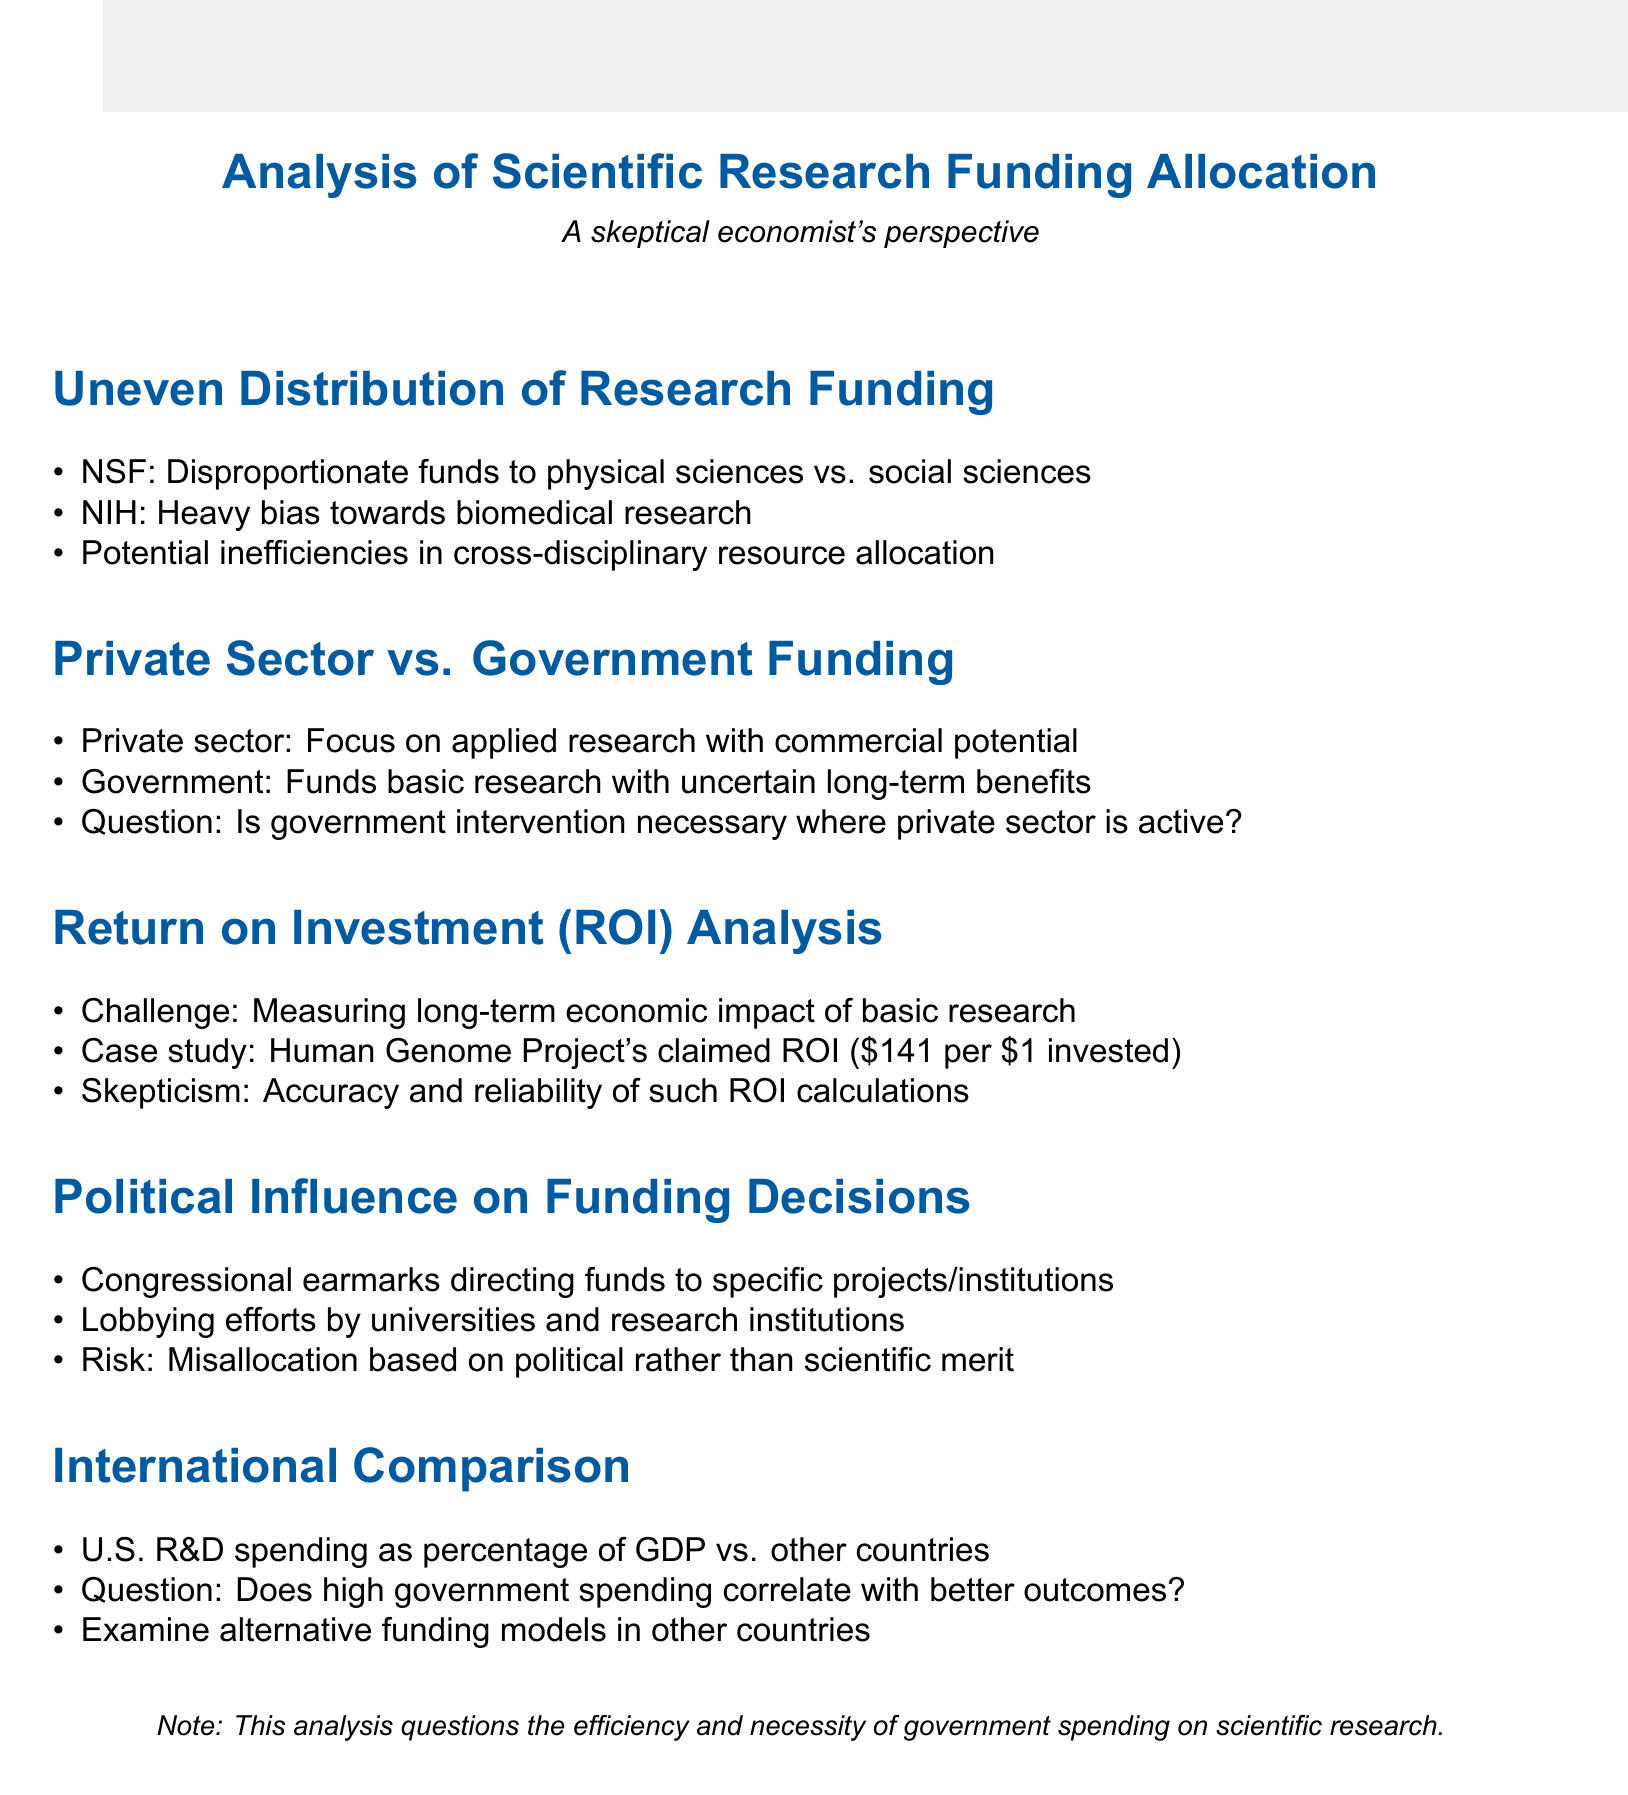What funding agency favors physical sciences? The document states that the National Science Foundation allocates disproportionate funds to physical sciences compared to social sciences.
Answer: National Science Foundation Which research field does the National Institutes of Health favor? The details mention that the NIH heavily favors biomedical research over other health-related fields.
Answer: Biomedical research What is the estimated ROI of the Human Genome Project? The document specifies the Human Genome Project's estimated ROI as $141 for every $1 invested.
Answer: $141 What is a risk mentioned regarding political influence on funding decisions? The document highlights the risk of misallocation of resources based on political rather than scientific merit.
Answer: Misallocation Which countries are compared to the U.S. in R&D spending? The document mentions China, Japan, and Germany in the context of international comparison of R&D spending.
Answer: China, Japan, Germany What type of research does the private sector focus on? The document states that the private sector invests more in applied research with immediate commercial potential.
Answer: Applied research What is questioned about government spending in relation to research outcomes? The document raises the question of whether high government spending correlates with better research outcomes.
Answer: High government spending correlation What is identified as a challenge in Return on Investment analysis? The document mentions the difficulty in measuring long-term economic impact of basic research as a challenge.
Answer: Measuring long-term economic impact 